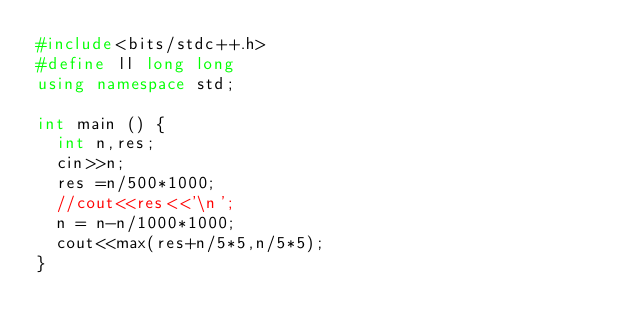<code> <loc_0><loc_0><loc_500><loc_500><_C++_>#include<bits/stdc++.h>
#define ll long long
using namespace std;

int main () {
  int n,res;
  cin>>n;
  res =n/500*1000;
  //cout<<res<<'\n';
  n = n-n/1000*1000;
  cout<<max(res+n/5*5,n/5*5);
}</code> 